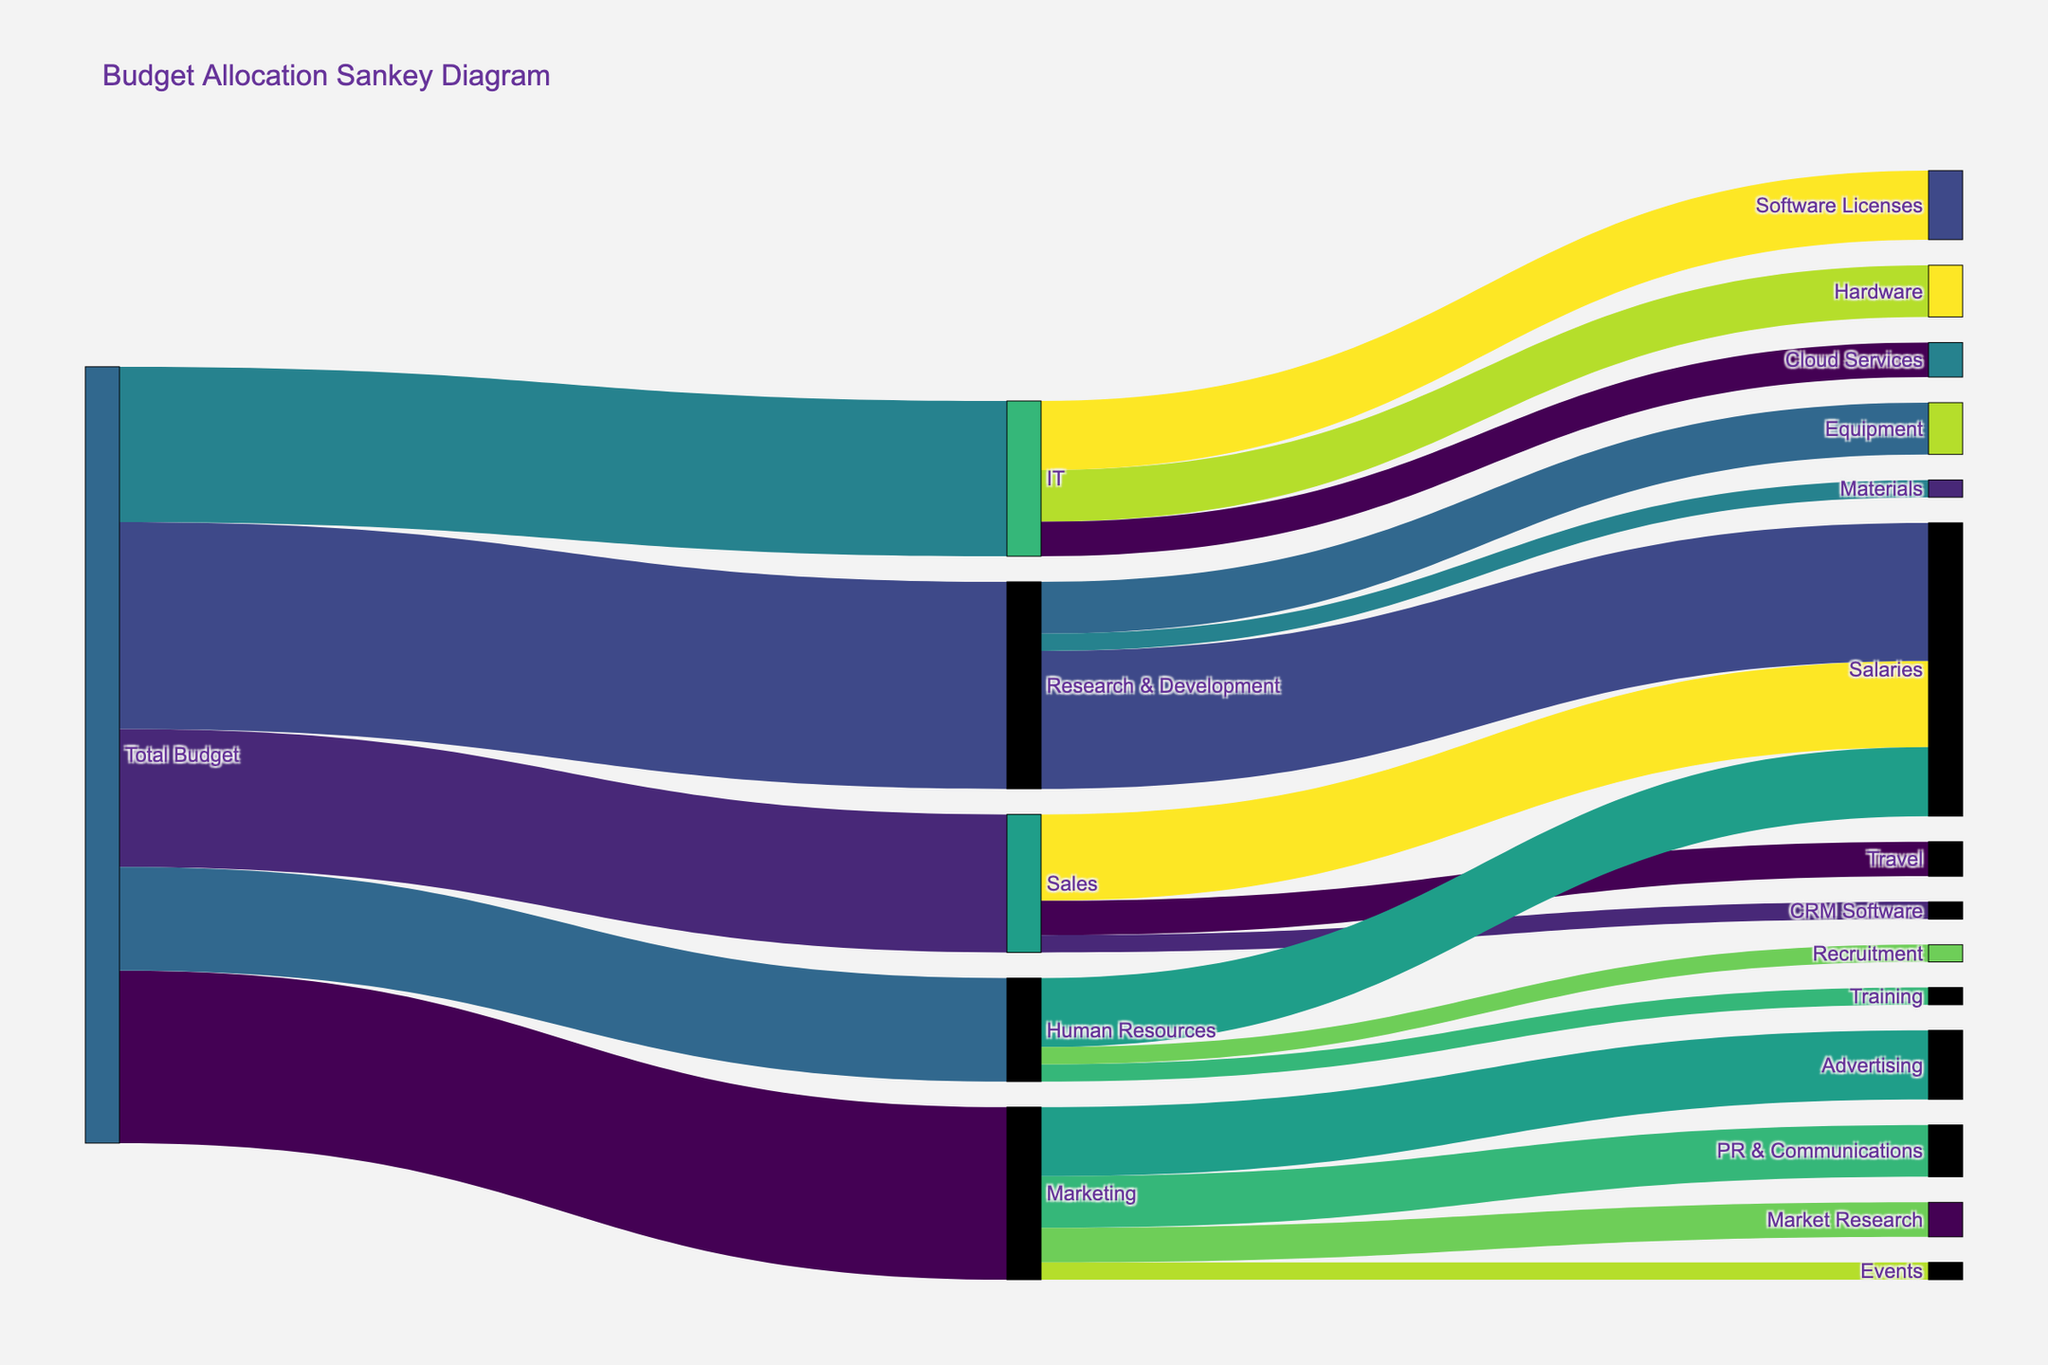What is the total budget allocated by the company? The total budget is shown at the starting node "Total Budget" in the Sankey diagram, which branches out to different departments. The sum of all outgoing values from "Total Budget" represents the total allocation. Adding up all the values: $500,000 (Marketing) + $400,000 (Sales) + $600,000 (R&D) + $300,000 (HR) + $450,000 (IT) = $2,250,000.
Answer: $2,250,000 Which department receives the highest budget allocation? To find this, we should look at the largest value branching out from the "Total Budget." The values are: Marketing ($500,000), Sales ($400,000), R&D ($600,000), HR ($300,000), and IT ($450,000). R&D at $600,000 receives the highest allocation.
Answer: Research & Development What amount is allocated to Sales for CRM Software? CRM Software is a subcategory under Sales. The link from Sales to CRM Software indicates an allocation of $50,000.
Answer: $50,000 How much budget is allocated to salaries across all departments combined? Sum the values related to salaries in each department: Marketing ($0), Sales ($250,000), R&D ($400,000), HR ($200,000), IT ($0). The total is $250,000 + $400,000 + $200,000 = $850,000.
Answer: $850,000 Compare the budget allocation to Market Research under Marketing and Recruitment under Human Resources. Which one is higher? Market Research under Marketing receives $100,000, and Recruitment under HR gets $50,000. Since $100,000 is greater than $50,000, Market Research has a higher budget.
Answer: Market Research What percentage of the IT budget is allocated to Software Licenses? IT has a total budget of $450,000. Software Licenses are allocated $200,000. The percentage is calculated as ($200,000 / $450,000) * 100 = 44.44%.
Answer: 44.44% What is the total budget allocated for Research & Development expenses other than salaries? R&D's budget has expenses for Equipment and Materials. Summing up these values: $150,000 (Equipment) + $50,000 (Materials) = $200,000.
Answer: $200,000 Compare the total budget allocation for Hardware under IT and Advertising under Marketing. Which one is greater and by how much? Hardware under IT has $150,000, and Advertising under Marketing has $200,000. Advertising is greater by $50,000 ($200,000 - $150,000).
Answer: Advertising, by $50,000 What is the combined budget allocation for Training and Recruitment under Human Resources? For HR, Training is allocated $50,000, and Recruitment is also allocated $50,000. Combined, the total is $50,000 + $50,000 = $100,000.
Answer: $100,000 Does the Sales department allocate more to CRM Software or Travel? Sales allocates $50,000 to CRM Software and $100,000 to Travel. Since $100,000 is greater than $50,000, Travel receives more allocation.
Answer: Travel 